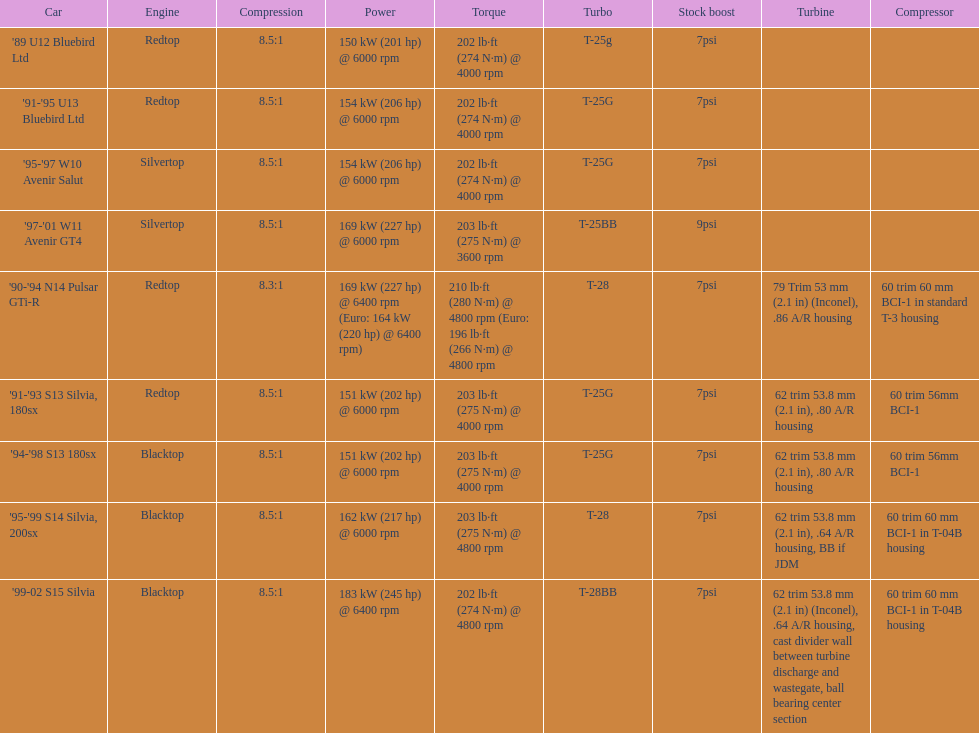Could you parse the entire table? {'header': ['Car', 'Engine', 'Compression', 'Power', 'Torque', 'Turbo', 'Stock boost', 'Turbine', 'Compressor'], 'rows': [["'89 U12 Bluebird Ltd", 'Redtop', '8.5:1', '150\xa0kW (201\xa0hp) @ 6000 rpm', '202\xa0lb·ft (274\xa0N·m) @ 4000 rpm', 'T-25g', '7psi', '', ''], ["'91-'95 U13 Bluebird Ltd", 'Redtop', '8.5:1', '154\xa0kW (206\xa0hp) @ 6000 rpm', '202\xa0lb·ft (274\xa0N·m) @ 4000 rpm', 'T-25G', '7psi', '', ''], ["'95-'97 W10 Avenir Salut", 'Silvertop', '8.5:1', '154\xa0kW (206\xa0hp) @ 6000 rpm', '202\xa0lb·ft (274\xa0N·m) @ 4000 rpm', 'T-25G', '7psi', '', ''], ["'97-'01 W11 Avenir GT4", 'Silvertop', '8.5:1', '169\xa0kW (227\xa0hp) @ 6000 rpm', '203\xa0lb·ft (275\xa0N·m) @ 3600 rpm', 'T-25BB', '9psi', '', ''], ["'90-'94 N14 Pulsar GTi-R", 'Redtop', '8.3:1', '169\xa0kW (227\xa0hp) @ 6400 rpm (Euro: 164\xa0kW (220\xa0hp) @ 6400 rpm)', '210\xa0lb·ft (280\xa0N·m) @ 4800 rpm (Euro: 196\xa0lb·ft (266\xa0N·m) @ 4800 rpm', 'T-28', '7psi', '79 Trim 53\xa0mm (2.1\xa0in) (Inconel), .86 A/R housing', '60 trim 60\xa0mm BCI-1 in standard T-3 housing'], ["'91-'93 S13 Silvia, 180sx", 'Redtop', '8.5:1', '151\xa0kW (202\xa0hp) @ 6000 rpm', '203\xa0lb·ft (275\xa0N·m) @ 4000 rpm', 'T-25G', '7psi', '62 trim 53.8\xa0mm (2.1\xa0in), .80 A/R housing', '60 trim 56mm BCI-1'], ["'94-'98 S13 180sx", 'Blacktop', '8.5:1', '151\xa0kW (202\xa0hp) @ 6000 rpm', '203\xa0lb·ft (275\xa0N·m) @ 4000 rpm', 'T-25G', '7psi', '62 trim 53.8\xa0mm (2.1\xa0in), .80 A/R housing', '60 trim 56mm BCI-1'], ["'95-'99 S14 Silvia, 200sx", 'Blacktop', '8.5:1', '162\xa0kW (217\xa0hp) @ 6000 rpm', '203\xa0lb·ft (275\xa0N·m) @ 4800 rpm', 'T-28', '7psi', '62 trim 53.8\xa0mm (2.1\xa0in), .64 A/R housing, BB if JDM', '60 trim 60\xa0mm BCI-1 in T-04B housing'], ["'99-02 S15 Silvia", 'Blacktop', '8.5:1', '183\xa0kW (245\xa0hp) @ 6400 rpm', '202\xa0lb·ft (274\xa0N·m) @ 4800 rpm', 'T-28BB', '7psi', '62 trim 53.8\xa0mm (2.1\xa0in) (Inconel), .64 A/R housing, cast divider wall between turbine discharge and wastegate, ball bearing center section', '60 trim 60\xa0mm BCI-1 in T-04B housing']]} Which engine(s) has the least amount of power? Redtop. 